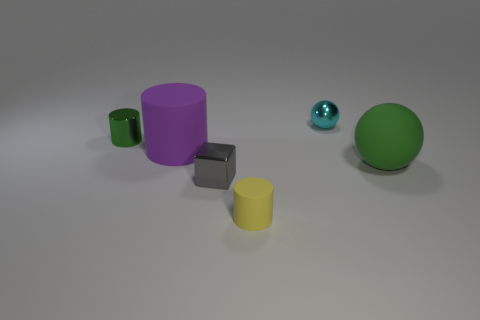Subtract all purple cylinders. How many cylinders are left? 2 Subtract all red cylinders. Subtract all purple blocks. How many cylinders are left? 3 Subtract all blue cubes. How many cyan balls are left? 1 Subtract all balls. Subtract all small objects. How many objects are left? 0 Add 3 small green metal things. How many small green metal things are left? 4 Add 3 tiny cyan shiny balls. How many tiny cyan shiny balls exist? 4 Add 2 small yellow matte objects. How many objects exist? 8 Subtract all yellow cylinders. How many cylinders are left? 2 Subtract 1 gray blocks. How many objects are left? 5 Subtract all spheres. How many objects are left? 4 